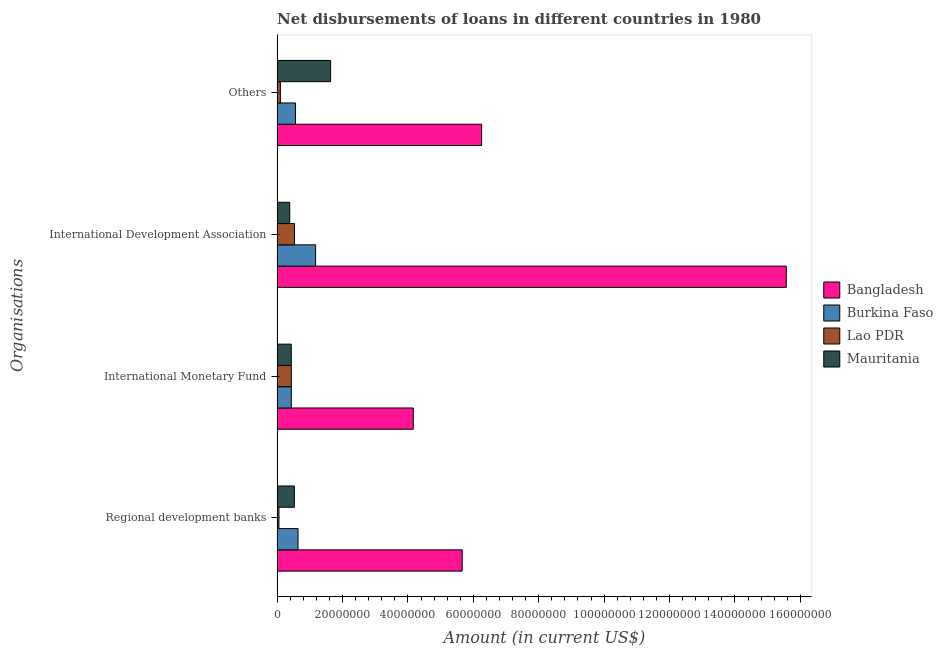How many different coloured bars are there?
Your answer should be compact. 4. How many groups of bars are there?
Offer a very short reply. 4. Are the number of bars per tick equal to the number of legend labels?
Give a very brief answer. Yes. Are the number of bars on each tick of the Y-axis equal?
Keep it short and to the point. Yes. How many bars are there on the 3rd tick from the bottom?
Offer a terse response. 4. What is the label of the 1st group of bars from the top?
Ensure brevity in your answer.  Others. What is the amount of loan disimbursed by regional development banks in Mauritania?
Provide a succinct answer. 5.28e+06. Across all countries, what is the maximum amount of loan disimbursed by international development association?
Offer a very short reply. 1.56e+08. Across all countries, what is the minimum amount of loan disimbursed by international monetary fund?
Your answer should be very brief. 4.33e+06. In which country was the amount of loan disimbursed by international development association maximum?
Provide a succinct answer. Bangladesh. In which country was the amount of loan disimbursed by international development association minimum?
Ensure brevity in your answer.  Mauritania. What is the total amount of loan disimbursed by other organisations in the graph?
Offer a very short reply. 8.55e+07. What is the difference between the amount of loan disimbursed by other organisations in Bangladesh and the amount of loan disimbursed by international monetary fund in Lao PDR?
Your answer should be compact. 5.82e+07. What is the average amount of loan disimbursed by regional development banks per country?
Your answer should be very brief. 1.72e+07. What is the difference between the amount of loan disimbursed by regional development banks and amount of loan disimbursed by international monetary fund in Burkina Faso?
Provide a short and direct response. 2.06e+06. What is the ratio of the amount of loan disimbursed by international monetary fund in Lao PDR to that in Bangladesh?
Keep it short and to the point. 0.1. Is the amount of loan disimbursed by international development association in Bangladesh less than that in Burkina Faso?
Your response must be concise. No. Is the difference between the amount of loan disimbursed by other organisations in Burkina Faso and Bangladesh greater than the difference between the amount of loan disimbursed by regional development banks in Burkina Faso and Bangladesh?
Provide a succinct answer. No. What is the difference between the highest and the second highest amount of loan disimbursed by regional development banks?
Offer a very short reply. 5.02e+07. What is the difference between the highest and the lowest amount of loan disimbursed by regional development banks?
Keep it short and to the point. 5.60e+07. Is the sum of the amount of loan disimbursed by regional development banks in Mauritania and Lao PDR greater than the maximum amount of loan disimbursed by international monetary fund across all countries?
Your answer should be compact. No. What does the 2nd bar from the bottom in International Development Association represents?
Keep it short and to the point. Burkina Faso. Is it the case that in every country, the sum of the amount of loan disimbursed by regional development banks and amount of loan disimbursed by international monetary fund is greater than the amount of loan disimbursed by international development association?
Offer a very short reply. No. How many countries are there in the graph?
Provide a succinct answer. 4. What is the difference between two consecutive major ticks on the X-axis?
Provide a short and direct response. 2.00e+07. Does the graph contain grids?
Offer a very short reply. No. How many legend labels are there?
Offer a terse response. 4. What is the title of the graph?
Provide a short and direct response. Net disbursements of loans in different countries in 1980. Does "Guinea-Bissau" appear as one of the legend labels in the graph?
Give a very brief answer. No. What is the label or title of the X-axis?
Your answer should be very brief. Amount (in current US$). What is the label or title of the Y-axis?
Your answer should be very brief. Organisations. What is the Amount (in current US$) in Bangladesh in Regional development banks?
Give a very brief answer. 5.66e+07. What is the Amount (in current US$) in Burkina Faso in Regional development banks?
Ensure brevity in your answer.  6.39e+06. What is the Amount (in current US$) in Lao PDR in Regional development banks?
Provide a short and direct response. 5.60e+05. What is the Amount (in current US$) in Mauritania in Regional development banks?
Your answer should be very brief. 5.28e+06. What is the Amount (in current US$) of Bangladesh in International Monetary Fund?
Keep it short and to the point. 4.16e+07. What is the Amount (in current US$) of Burkina Faso in International Monetary Fund?
Give a very brief answer. 4.33e+06. What is the Amount (in current US$) in Lao PDR in International Monetary Fund?
Your answer should be very brief. 4.33e+06. What is the Amount (in current US$) of Mauritania in International Monetary Fund?
Your response must be concise. 4.33e+06. What is the Amount (in current US$) in Bangladesh in International Development Association?
Provide a succinct answer. 1.56e+08. What is the Amount (in current US$) in Burkina Faso in International Development Association?
Your answer should be compact. 1.18e+07. What is the Amount (in current US$) in Lao PDR in International Development Association?
Provide a short and direct response. 5.30e+06. What is the Amount (in current US$) of Mauritania in International Development Association?
Ensure brevity in your answer.  3.86e+06. What is the Amount (in current US$) in Bangladesh in Others?
Your response must be concise. 6.25e+07. What is the Amount (in current US$) of Burkina Faso in Others?
Your answer should be compact. 5.61e+06. What is the Amount (in current US$) in Lao PDR in Others?
Your response must be concise. 1.00e+06. What is the Amount (in current US$) of Mauritania in Others?
Your answer should be compact. 1.63e+07. Across all Organisations, what is the maximum Amount (in current US$) in Bangladesh?
Offer a very short reply. 1.56e+08. Across all Organisations, what is the maximum Amount (in current US$) of Burkina Faso?
Keep it short and to the point. 1.18e+07. Across all Organisations, what is the maximum Amount (in current US$) in Lao PDR?
Your answer should be very brief. 5.30e+06. Across all Organisations, what is the maximum Amount (in current US$) of Mauritania?
Your answer should be very brief. 1.63e+07. Across all Organisations, what is the minimum Amount (in current US$) in Bangladesh?
Ensure brevity in your answer.  4.16e+07. Across all Organisations, what is the minimum Amount (in current US$) of Burkina Faso?
Make the answer very short. 4.33e+06. Across all Organisations, what is the minimum Amount (in current US$) in Lao PDR?
Your answer should be compact. 5.60e+05. Across all Organisations, what is the minimum Amount (in current US$) of Mauritania?
Your answer should be very brief. 3.86e+06. What is the total Amount (in current US$) of Bangladesh in the graph?
Offer a very short reply. 3.16e+08. What is the total Amount (in current US$) in Burkina Faso in the graph?
Your answer should be compact. 2.81e+07. What is the total Amount (in current US$) in Lao PDR in the graph?
Give a very brief answer. 1.12e+07. What is the total Amount (in current US$) in Mauritania in the graph?
Make the answer very short. 2.98e+07. What is the difference between the Amount (in current US$) of Bangladesh in Regional development banks and that in International Monetary Fund?
Offer a very short reply. 1.50e+07. What is the difference between the Amount (in current US$) of Burkina Faso in Regional development banks and that in International Monetary Fund?
Provide a short and direct response. 2.06e+06. What is the difference between the Amount (in current US$) in Lao PDR in Regional development banks and that in International Monetary Fund?
Ensure brevity in your answer.  -3.77e+06. What is the difference between the Amount (in current US$) of Mauritania in Regional development banks and that in International Monetary Fund?
Offer a terse response. 9.45e+05. What is the difference between the Amount (in current US$) in Bangladesh in Regional development banks and that in International Development Association?
Your response must be concise. -9.91e+07. What is the difference between the Amount (in current US$) of Burkina Faso in Regional development banks and that in International Development Association?
Give a very brief answer. -5.37e+06. What is the difference between the Amount (in current US$) of Lao PDR in Regional development banks and that in International Development Association?
Your answer should be very brief. -4.74e+06. What is the difference between the Amount (in current US$) of Mauritania in Regional development banks and that in International Development Association?
Ensure brevity in your answer.  1.42e+06. What is the difference between the Amount (in current US$) of Bangladesh in Regional development banks and that in Others?
Your answer should be compact. -5.94e+06. What is the difference between the Amount (in current US$) in Burkina Faso in Regional development banks and that in Others?
Provide a succinct answer. 7.79e+05. What is the difference between the Amount (in current US$) in Lao PDR in Regional development banks and that in Others?
Your response must be concise. -4.40e+05. What is the difference between the Amount (in current US$) in Mauritania in Regional development banks and that in Others?
Your response must be concise. -1.11e+07. What is the difference between the Amount (in current US$) of Bangladesh in International Monetary Fund and that in International Development Association?
Make the answer very short. -1.14e+08. What is the difference between the Amount (in current US$) of Burkina Faso in International Monetary Fund and that in International Development Association?
Keep it short and to the point. -7.43e+06. What is the difference between the Amount (in current US$) in Lao PDR in International Monetary Fund and that in International Development Association?
Provide a short and direct response. -9.68e+05. What is the difference between the Amount (in current US$) of Mauritania in International Monetary Fund and that in International Development Association?
Your answer should be compact. 4.74e+05. What is the difference between the Amount (in current US$) of Bangladesh in International Monetary Fund and that in Others?
Offer a terse response. -2.09e+07. What is the difference between the Amount (in current US$) in Burkina Faso in International Monetary Fund and that in Others?
Your response must be concise. -1.28e+06. What is the difference between the Amount (in current US$) of Lao PDR in International Monetary Fund and that in Others?
Offer a very short reply. 3.33e+06. What is the difference between the Amount (in current US$) in Mauritania in International Monetary Fund and that in Others?
Give a very brief answer. -1.20e+07. What is the difference between the Amount (in current US$) in Bangladesh in International Development Association and that in Others?
Your answer should be very brief. 9.32e+07. What is the difference between the Amount (in current US$) in Burkina Faso in International Development Association and that in Others?
Make the answer very short. 6.15e+06. What is the difference between the Amount (in current US$) of Lao PDR in International Development Association and that in Others?
Provide a succinct answer. 4.30e+06. What is the difference between the Amount (in current US$) in Mauritania in International Development Association and that in Others?
Your answer should be very brief. -1.25e+07. What is the difference between the Amount (in current US$) in Bangladesh in Regional development banks and the Amount (in current US$) in Burkina Faso in International Monetary Fund?
Your answer should be compact. 5.23e+07. What is the difference between the Amount (in current US$) in Bangladesh in Regional development banks and the Amount (in current US$) in Lao PDR in International Monetary Fund?
Make the answer very short. 5.23e+07. What is the difference between the Amount (in current US$) of Bangladesh in Regional development banks and the Amount (in current US$) of Mauritania in International Monetary Fund?
Make the answer very short. 5.23e+07. What is the difference between the Amount (in current US$) in Burkina Faso in Regional development banks and the Amount (in current US$) in Lao PDR in International Monetary Fund?
Offer a very short reply. 2.06e+06. What is the difference between the Amount (in current US$) of Burkina Faso in Regional development banks and the Amount (in current US$) of Mauritania in International Monetary Fund?
Give a very brief answer. 2.06e+06. What is the difference between the Amount (in current US$) of Lao PDR in Regional development banks and the Amount (in current US$) of Mauritania in International Monetary Fund?
Your response must be concise. -3.77e+06. What is the difference between the Amount (in current US$) in Bangladesh in Regional development banks and the Amount (in current US$) in Burkina Faso in International Development Association?
Your answer should be very brief. 4.48e+07. What is the difference between the Amount (in current US$) of Bangladesh in Regional development banks and the Amount (in current US$) of Lao PDR in International Development Association?
Keep it short and to the point. 5.13e+07. What is the difference between the Amount (in current US$) in Bangladesh in Regional development banks and the Amount (in current US$) in Mauritania in International Development Association?
Ensure brevity in your answer.  5.27e+07. What is the difference between the Amount (in current US$) of Burkina Faso in Regional development banks and the Amount (in current US$) of Lao PDR in International Development Association?
Keep it short and to the point. 1.09e+06. What is the difference between the Amount (in current US$) of Burkina Faso in Regional development banks and the Amount (in current US$) of Mauritania in International Development Association?
Your answer should be very brief. 2.53e+06. What is the difference between the Amount (in current US$) of Lao PDR in Regional development banks and the Amount (in current US$) of Mauritania in International Development Association?
Ensure brevity in your answer.  -3.30e+06. What is the difference between the Amount (in current US$) of Bangladesh in Regional development banks and the Amount (in current US$) of Burkina Faso in Others?
Offer a terse response. 5.10e+07. What is the difference between the Amount (in current US$) of Bangladesh in Regional development banks and the Amount (in current US$) of Lao PDR in Others?
Your answer should be compact. 5.56e+07. What is the difference between the Amount (in current US$) in Bangladesh in Regional development banks and the Amount (in current US$) in Mauritania in Others?
Make the answer very short. 4.02e+07. What is the difference between the Amount (in current US$) in Burkina Faso in Regional development banks and the Amount (in current US$) in Lao PDR in Others?
Your response must be concise. 5.39e+06. What is the difference between the Amount (in current US$) of Burkina Faso in Regional development banks and the Amount (in current US$) of Mauritania in Others?
Provide a succinct answer. -9.96e+06. What is the difference between the Amount (in current US$) of Lao PDR in Regional development banks and the Amount (in current US$) of Mauritania in Others?
Offer a very short reply. -1.58e+07. What is the difference between the Amount (in current US$) of Bangladesh in International Monetary Fund and the Amount (in current US$) of Burkina Faso in International Development Association?
Offer a very short reply. 2.99e+07. What is the difference between the Amount (in current US$) in Bangladesh in International Monetary Fund and the Amount (in current US$) in Lao PDR in International Development Association?
Keep it short and to the point. 3.63e+07. What is the difference between the Amount (in current US$) of Bangladesh in International Monetary Fund and the Amount (in current US$) of Mauritania in International Development Association?
Offer a very short reply. 3.78e+07. What is the difference between the Amount (in current US$) in Burkina Faso in International Monetary Fund and the Amount (in current US$) in Lao PDR in International Development Association?
Provide a succinct answer. -9.68e+05. What is the difference between the Amount (in current US$) in Burkina Faso in International Monetary Fund and the Amount (in current US$) in Mauritania in International Development Association?
Give a very brief answer. 4.74e+05. What is the difference between the Amount (in current US$) in Lao PDR in International Monetary Fund and the Amount (in current US$) in Mauritania in International Development Association?
Your answer should be compact. 4.74e+05. What is the difference between the Amount (in current US$) of Bangladesh in International Monetary Fund and the Amount (in current US$) of Burkina Faso in Others?
Offer a very short reply. 3.60e+07. What is the difference between the Amount (in current US$) of Bangladesh in International Monetary Fund and the Amount (in current US$) of Lao PDR in Others?
Offer a terse response. 4.06e+07. What is the difference between the Amount (in current US$) of Bangladesh in International Monetary Fund and the Amount (in current US$) of Mauritania in Others?
Keep it short and to the point. 2.53e+07. What is the difference between the Amount (in current US$) in Burkina Faso in International Monetary Fund and the Amount (in current US$) in Lao PDR in Others?
Offer a very short reply. 3.33e+06. What is the difference between the Amount (in current US$) of Burkina Faso in International Monetary Fund and the Amount (in current US$) of Mauritania in Others?
Offer a very short reply. -1.20e+07. What is the difference between the Amount (in current US$) in Lao PDR in International Monetary Fund and the Amount (in current US$) in Mauritania in Others?
Make the answer very short. -1.20e+07. What is the difference between the Amount (in current US$) of Bangladesh in International Development Association and the Amount (in current US$) of Burkina Faso in Others?
Your answer should be compact. 1.50e+08. What is the difference between the Amount (in current US$) of Bangladesh in International Development Association and the Amount (in current US$) of Lao PDR in Others?
Your answer should be very brief. 1.55e+08. What is the difference between the Amount (in current US$) of Bangladesh in International Development Association and the Amount (in current US$) of Mauritania in Others?
Your answer should be compact. 1.39e+08. What is the difference between the Amount (in current US$) in Burkina Faso in International Development Association and the Amount (in current US$) in Lao PDR in Others?
Provide a succinct answer. 1.08e+07. What is the difference between the Amount (in current US$) of Burkina Faso in International Development Association and the Amount (in current US$) of Mauritania in Others?
Provide a succinct answer. -4.58e+06. What is the difference between the Amount (in current US$) in Lao PDR in International Development Association and the Amount (in current US$) in Mauritania in Others?
Give a very brief answer. -1.10e+07. What is the average Amount (in current US$) in Bangladesh per Organisations?
Your answer should be compact. 7.91e+07. What is the average Amount (in current US$) of Burkina Faso per Organisations?
Your response must be concise. 7.03e+06. What is the average Amount (in current US$) in Lao PDR per Organisations?
Provide a succinct answer. 2.80e+06. What is the average Amount (in current US$) in Mauritania per Organisations?
Your answer should be very brief. 7.45e+06. What is the difference between the Amount (in current US$) in Bangladesh and Amount (in current US$) in Burkina Faso in Regional development banks?
Provide a succinct answer. 5.02e+07. What is the difference between the Amount (in current US$) in Bangladesh and Amount (in current US$) in Lao PDR in Regional development banks?
Provide a succinct answer. 5.60e+07. What is the difference between the Amount (in current US$) in Bangladesh and Amount (in current US$) in Mauritania in Regional development banks?
Provide a succinct answer. 5.13e+07. What is the difference between the Amount (in current US$) in Burkina Faso and Amount (in current US$) in Lao PDR in Regional development banks?
Your response must be concise. 5.83e+06. What is the difference between the Amount (in current US$) in Burkina Faso and Amount (in current US$) in Mauritania in Regional development banks?
Make the answer very short. 1.12e+06. What is the difference between the Amount (in current US$) in Lao PDR and Amount (in current US$) in Mauritania in Regional development banks?
Make the answer very short. -4.72e+06. What is the difference between the Amount (in current US$) in Bangladesh and Amount (in current US$) in Burkina Faso in International Monetary Fund?
Your answer should be very brief. 3.73e+07. What is the difference between the Amount (in current US$) in Bangladesh and Amount (in current US$) in Lao PDR in International Monetary Fund?
Your answer should be very brief. 3.73e+07. What is the difference between the Amount (in current US$) in Bangladesh and Amount (in current US$) in Mauritania in International Monetary Fund?
Keep it short and to the point. 3.73e+07. What is the difference between the Amount (in current US$) in Burkina Faso and Amount (in current US$) in Lao PDR in International Monetary Fund?
Offer a terse response. 0. What is the difference between the Amount (in current US$) in Bangladesh and Amount (in current US$) in Burkina Faso in International Development Association?
Make the answer very short. 1.44e+08. What is the difference between the Amount (in current US$) of Bangladesh and Amount (in current US$) of Lao PDR in International Development Association?
Your response must be concise. 1.50e+08. What is the difference between the Amount (in current US$) in Bangladesh and Amount (in current US$) in Mauritania in International Development Association?
Your answer should be compact. 1.52e+08. What is the difference between the Amount (in current US$) in Burkina Faso and Amount (in current US$) in Lao PDR in International Development Association?
Your answer should be very brief. 6.46e+06. What is the difference between the Amount (in current US$) of Burkina Faso and Amount (in current US$) of Mauritania in International Development Association?
Your answer should be compact. 7.91e+06. What is the difference between the Amount (in current US$) of Lao PDR and Amount (in current US$) of Mauritania in International Development Association?
Make the answer very short. 1.44e+06. What is the difference between the Amount (in current US$) of Bangladesh and Amount (in current US$) of Burkina Faso in Others?
Offer a terse response. 5.69e+07. What is the difference between the Amount (in current US$) of Bangladesh and Amount (in current US$) of Lao PDR in Others?
Make the answer very short. 6.15e+07. What is the difference between the Amount (in current US$) of Bangladesh and Amount (in current US$) of Mauritania in Others?
Your response must be concise. 4.62e+07. What is the difference between the Amount (in current US$) of Burkina Faso and Amount (in current US$) of Lao PDR in Others?
Give a very brief answer. 4.61e+06. What is the difference between the Amount (in current US$) of Burkina Faso and Amount (in current US$) of Mauritania in Others?
Make the answer very short. -1.07e+07. What is the difference between the Amount (in current US$) in Lao PDR and Amount (in current US$) in Mauritania in Others?
Offer a very short reply. -1.53e+07. What is the ratio of the Amount (in current US$) of Bangladesh in Regional development banks to that in International Monetary Fund?
Make the answer very short. 1.36. What is the ratio of the Amount (in current US$) of Burkina Faso in Regional development banks to that in International Monetary Fund?
Give a very brief answer. 1.48. What is the ratio of the Amount (in current US$) of Lao PDR in Regional development banks to that in International Monetary Fund?
Provide a short and direct response. 0.13. What is the ratio of the Amount (in current US$) of Mauritania in Regional development banks to that in International Monetary Fund?
Offer a terse response. 1.22. What is the ratio of the Amount (in current US$) of Bangladesh in Regional development banks to that in International Development Association?
Provide a short and direct response. 0.36. What is the ratio of the Amount (in current US$) in Burkina Faso in Regional development banks to that in International Development Association?
Your response must be concise. 0.54. What is the ratio of the Amount (in current US$) of Lao PDR in Regional development banks to that in International Development Association?
Offer a very short reply. 0.11. What is the ratio of the Amount (in current US$) of Mauritania in Regional development banks to that in International Development Association?
Give a very brief answer. 1.37. What is the ratio of the Amount (in current US$) of Bangladesh in Regional development banks to that in Others?
Ensure brevity in your answer.  0.9. What is the ratio of the Amount (in current US$) in Burkina Faso in Regional development banks to that in Others?
Keep it short and to the point. 1.14. What is the ratio of the Amount (in current US$) of Lao PDR in Regional development banks to that in Others?
Your answer should be very brief. 0.56. What is the ratio of the Amount (in current US$) of Mauritania in Regional development banks to that in Others?
Your answer should be very brief. 0.32. What is the ratio of the Amount (in current US$) of Bangladesh in International Monetary Fund to that in International Development Association?
Your answer should be very brief. 0.27. What is the ratio of the Amount (in current US$) of Burkina Faso in International Monetary Fund to that in International Development Association?
Offer a very short reply. 0.37. What is the ratio of the Amount (in current US$) in Lao PDR in International Monetary Fund to that in International Development Association?
Your answer should be very brief. 0.82. What is the ratio of the Amount (in current US$) in Mauritania in International Monetary Fund to that in International Development Association?
Ensure brevity in your answer.  1.12. What is the ratio of the Amount (in current US$) in Bangladesh in International Monetary Fund to that in Others?
Your answer should be very brief. 0.67. What is the ratio of the Amount (in current US$) in Burkina Faso in International Monetary Fund to that in Others?
Offer a very short reply. 0.77. What is the ratio of the Amount (in current US$) of Lao PDR in International Monetary Fund to that in Others?
Keep it short and to the point. 4.33. What is the ratio of the Amount (in current US$) in Mauritania in International Monetary Fund to that in Others?
Ensure brevity in your answer.  0.27. What is the ratio of the Amount (in current US$) in Bangladesh in International Development Association to that in Others?
Make the answer very short. 2.49. What is the ratio of the Amount (in current US$) of Burkina Faso in International Development Association to that in Others?
Offer a terse response. 2.1. What is the ratio of the Amount (in current US$) of Lao PDR in International Development Association to that in Others?
Keep it short and to the point. 5.3. What is the ratio of the Amount (in current US$) of Mauritania in International Development Association to that in Others?
Ensure brevity in your answer.  0.24. What is the difference between the highest and the second highest Amount (in current US$) of Bangladesh?
Provide a short and direct response. 9.32e+07. What is the difference between the highest and the second highest Amount (in current US$) in Burkina Faso?
Your answer should be compact. 5.37e+06. What is the difference between the highest and the second highest Amount (in current US$) of Lao PDR?
Make the answer very short. 9.68e+05. What is the difference between the highest and the second highest Amount (in current US$) in Mauritania?
Provide a short and direct response. 1.11e+07. What is the difference between the highest and the lowest Amount (in current US$) of Bangladesh?
Ensure brevity in your answer.  1.14e+08. What is the difference between the highest and the lowest Amount (in current US$) in Burkina Faso?
Give a very brief answer. 7.43e+06. What is the difference between the highest and the lowest Amount (in current US$) of Lao PDR?
Offer a terse response. 4.74e+06. What is the difference between the highest and the lowest Amount (in current US$) of Mauritania?
Keep it short and to the point. 1.25e+07. 